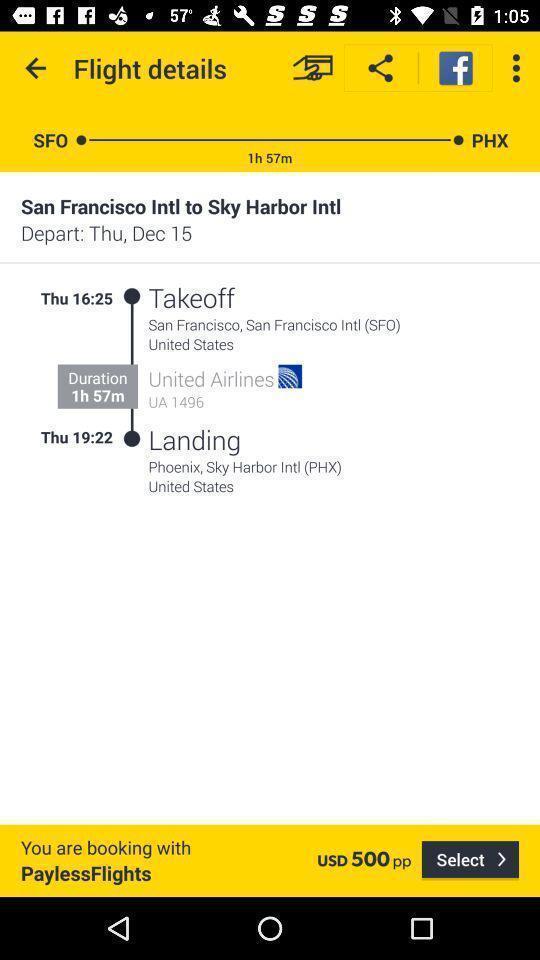Summarize the main components in this picture. Screen displaying the flight details. 